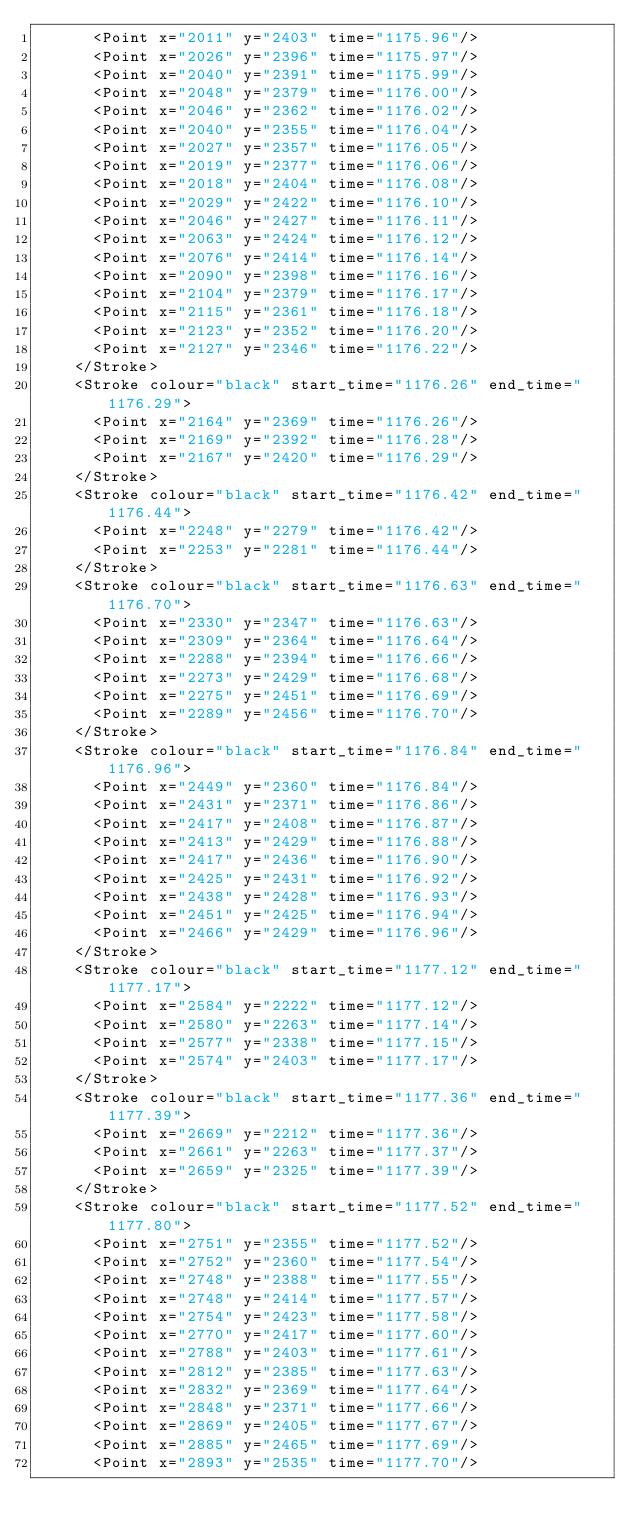<code> <loc_0><loc_0><loc_500><loc_500><_XML_>      <Point x="2011" y="2403" time="1175.96"/>
      <Point x="2026" y="2396" time="1175.97"/>
      <Point x="2040" y="2391" time="1175.99"/>
      <Point x="2048" y="2379" time="1176.00"/>
      <Point x="2046" y="2362" time="1176.02"/>
      <Point x="2040" y="2355" time="1176.04"/>
      <Point x="2027" y="2357" time="1176.05"/>
      <Point x="2019" y="2377" time="1176.06"/>
      <Point x="2018" y="2404" time="1176.08"/>
      <Point x="2029" y="2422" time="1176.10"/>
      <Point x="2046" y="2427" time="1176.11"/>
      <Point x="2063" y="2424" time="1176.12"/>
      <Point x="2076" y="2414" time="1176.14"/>
      <Point x="2090" y="2398" time="1176.16"/>
      <Point x="2104" y="2379" time="1176.17"/>
      <Point x="2115" y="2361" time="1176.18"/>
      <Point x="2123" y="2352" time="1176.20"/>
      <Point x="2127" y="2346" time="1176.22"/>
    </Stroke>
    <Stroke colour="black" start_time="1176.26" end_time="1176.29">
      <Point x="2164" y="2369" time="1176.26"/>
      <Point x="2169" y="2392" time="1176.28"/>
      <Point x="2167" y="2420" time="1176.29"/>
    </Stroke>
    <Stroke colour="black" start_time="1176.42" end_time="1176.44">
      <Point x="2248" y="2279" time="1176.42"/>
      <Point x="2253" y="2281" time="1176.44"/>
    </Stroke>
    <Stroke colour="black" start_time="1176.63" end_time="1176.70">
      <Point x="2330" y="2347" time="1176.63"/>
      <Point x="2309" y="2364" time="1176.64"/>
      <Point x="2288" y="2394" time="1176.66"/>
      <Point x="2273" y="2429" time="1176.68"/>
      <Point x="2275" y="2451" time="1176.69"/>
      <Point x="2289" y="2456" time="1176.70"/>
    </Stroke>
    <Stroke colour="black" start_time="1176.84" end_time="1176.96">
      <Point x="2449" y="2360" time="1176.84"/>
      <Point x="2431" y="2371" time="1176.86"/>
      <Point x="2417" y="2408" time="1176.87"/>
      <Point x="2413" y="2429" time="1176.88"/>
      <Point x="2417" y="2436" time="1176.90"/>
      <Point x="2425" y="2431" time="1176.92"/>
      <Point x="2438" y="2428" time="1176.93"/>
      <Point x="2451" y="2425" time="1176.94"/>
      <Point x="2466" y="2429" time="1176.96"/>
    </Stroke>
    <Stroke colour="black" start_time="1177.12" end_time="1177.17">
      <Point x="2584" y="2222" time="1177.12"/>
      <Point x="2580" y="2263" time="1177.14"/>
      <Point x="2577" y="2338" time="1177.15"/>
      <Point x="2574" y="2403" time="1177.17"/>
    </Stroke>
    <Stroke colour="black" start_time="1177.36" end_time="1177.39">
      <Point x="2669" y="2212" time="1177.36"/>
      <Point x="2661" y="2263" time="1177.37"/>
      <Point x="2659" y="2325" time="1177.39"/>
    </Stroke>
    <Stroke colour="black" start_time="1177.52" end_time="1177.80">
      <Point x="2751" y="2355" time="1177.52"/>
      <Point x="2752" y="2360" time="1177.54"/>
      <Point x="2748" y="2388" time="1177.55"/>
      <Point x="2748" y="2414" time="1177.57"/>
      <Point x="2754" y="2423" time="1177.58"/>
      <Point x="2770" y="2417" time="1177.60"/>
      <Point x="2788" y="2403" time="1177.61"/>
      <Point x="2812" y="2385" time="1177.63"/>
      <Point x="2832" y="2369" time="1177.64"/>
      <Point x="2848" y="2371" time="1177.66"/>
      <Point x="2869" y="2405" time="1177.67"/>
      <Point x="2885" y="2465" time="1177.69"/>
      <Point x="2893" y="2535" time="1177.70"/></code> 